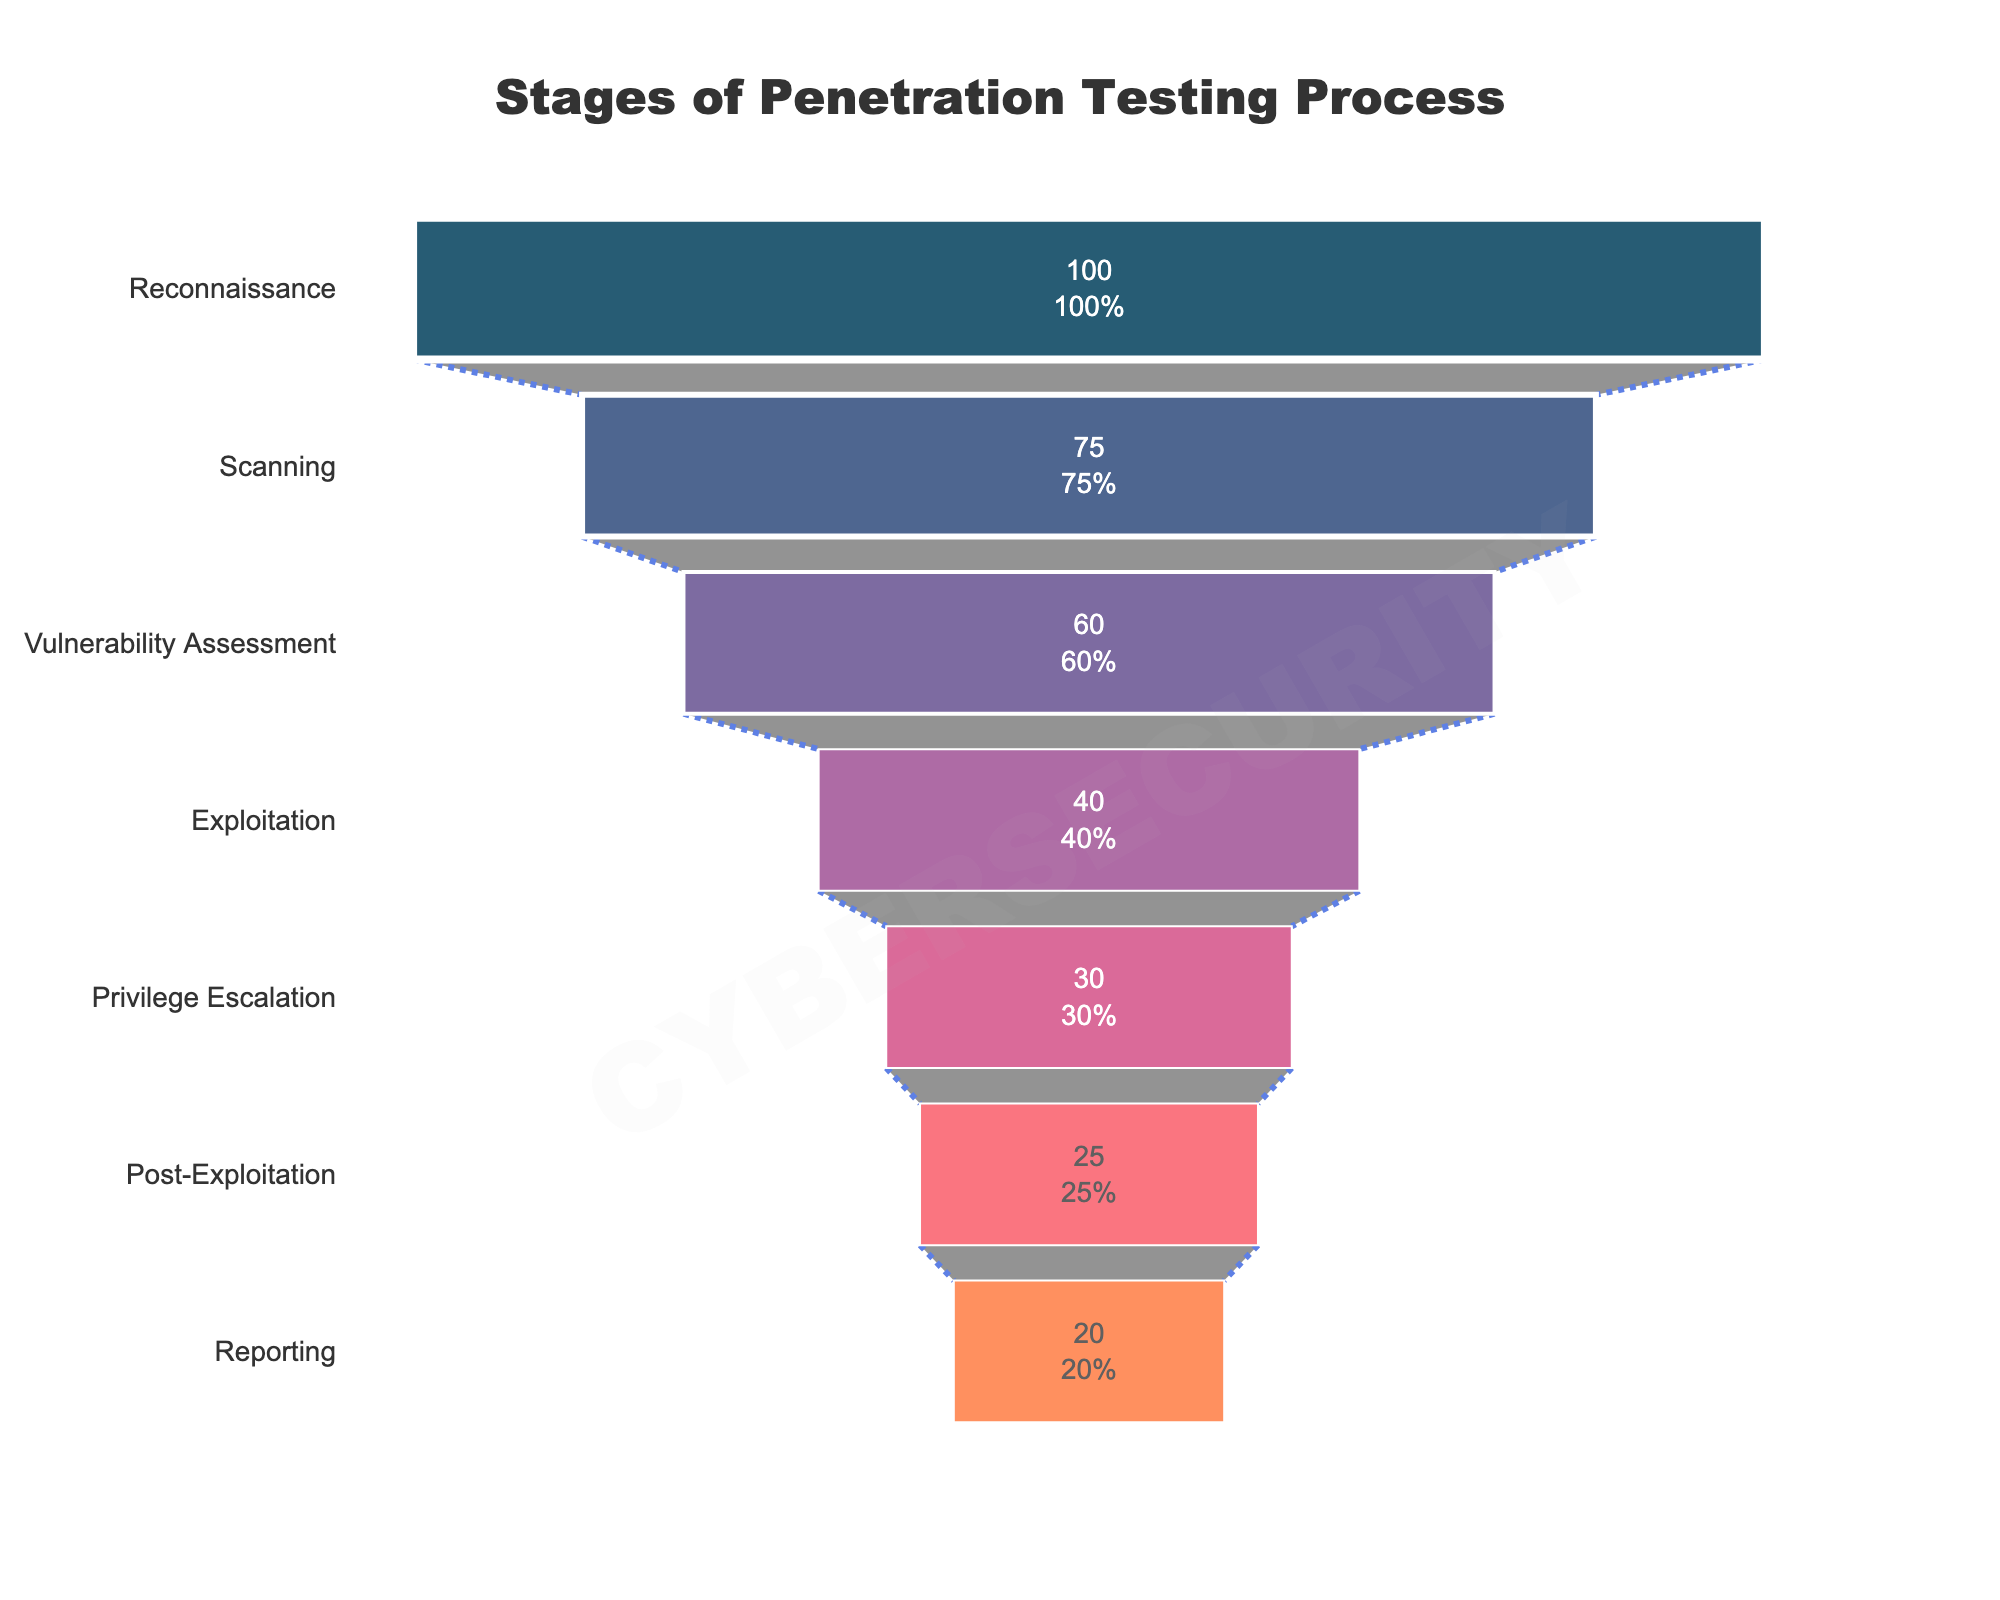What is the title of the funnel chart? The title of the funnel chart is usually displayed at the top center of the chart. It provides context to the viewer about what the chart represents. The title in this case is "Stages of Penetration Testing Process"
Answer: Stages of Penetration Testing Process Which stage has the highest number of activities? To find the stage with the highest number of activities, look at the topmost section of the funnel chart since the largest portion typically corresponds to the highest number. In this chart, "Reconnaissance" has the highest number of activities with a value of 100
Answer: Reconnaissance How many activities are associated with the Exploitation stage? Locate the "Exploitation" stage on the funnel chart and read the number of activities listed inside it. The number shown is 40
Answer: 40 What percentage of activities are associated with the Post-Exploitation stage relative to the initial total? The funnel chart shows both the number and percentage of activities at each stage. For the Post-Exploitation stage, the number of activities is 25, and the percentage of the initial total is displayed next to it
Answer: 25% What is the difference in the number of activities between the Scanning and Reporting stages? Look at the number of activities associated with both stages on the chart. Scanning has 75 activities and Reporting has 20 activities. Calculate the difference: 75 - 20 = 55
Answer: 55 Which stage has more activities: Vulnerability Assessment or Privilege Escalation? Compare the number of activities between the two stages on the funnel chart. Vulnerability Assessment has 60 activities, while Privilege Escalation has 30 activities. Hence, Vulnerability Assessment has more activities
Answer: Vulnerability Assessment How does the number of activities in the Exploitation stage compare to the Privilege Escalation stage? Check the number of activities for both stages. Exploitation has 40 activities and Privilege Escalation has 30. Exploitation has more activities than Privilege Escalation
Answer: Exploitation has more What proportion of the activities are completed by the Reporting stage? To find the proportion of activities completed by the Reporting stage, look at the percentage value next to the Reporting stage. The funnel chart shows it, representing the completion relative to the initial total
Answer: 20% What is the total number of activities from the Reconnaissance to the Privilege Escalation stages? Add the numbers of activities from Reconnaissance, Scanning, Vulnerability Assessment, Exploitation, and Privilege Escalation. So, 100 + 75 + 60 + 40 + 30 = 305
Answer: 305 Which stages have a decrement of 15 activities each when moving to the next stage? Compare each stage's number of activities to the next one down. Both the shift from Reconnaissance to Scanning (100 to 75) and from Vulnerability Assessment to Exploitation (60 to 40) represent a decrement of 15 activities
Answer: Reconnaissance to Scanning, Vulnerability Assessment to Exploitation 